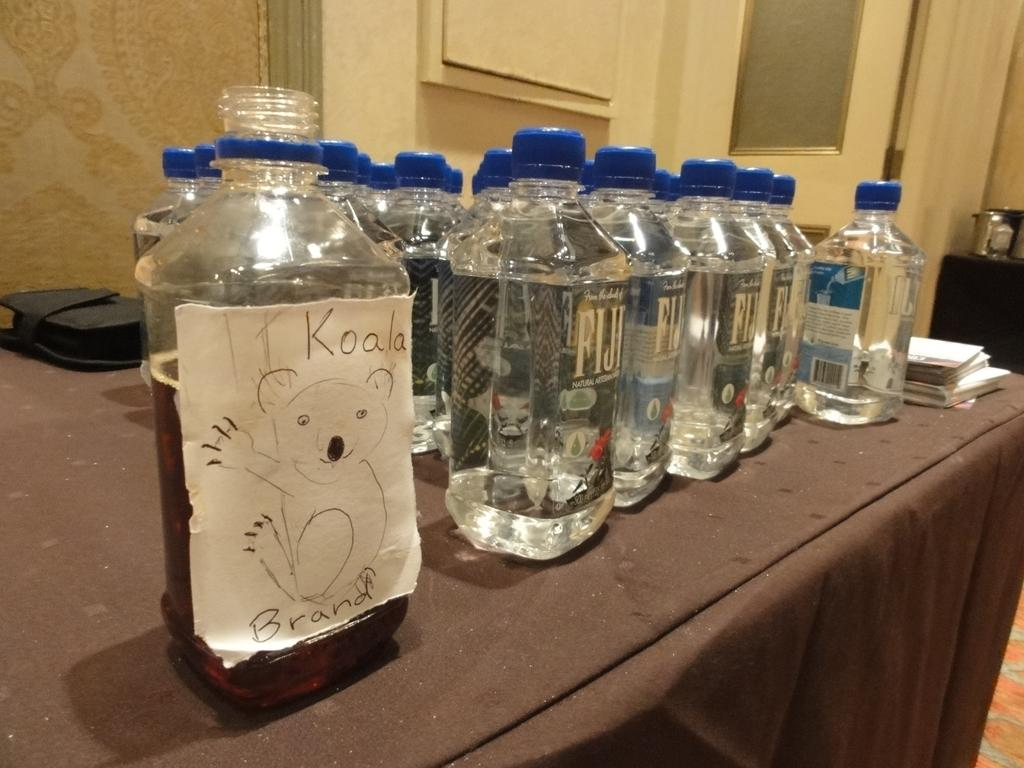What is the main subject of the image? The main subject of the image is a bunch of water bottles. Where are the water bottles located in the image? The water bottles are on a table. What grade did the volleyball player achieve in the record-breaking match? There is no volleyball player or record-breaking match present in the image; it only features a bunch of water bottles on a table. 